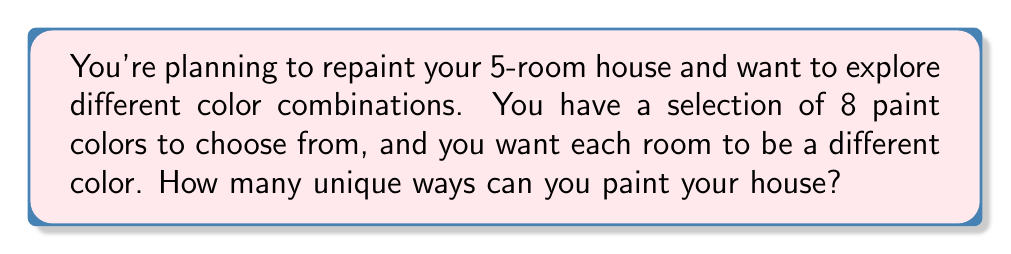Can you solve this math problem? To solve this problem, we need to use the concept of permutations from discrete mathematics. Here's a step-by-step explanation:

1. We have 5 rooms to paint, and each room must be a different color.
2. We have 8 colors to choose from.
3. This scenario is a permutation without repetition, as we're selecting colors without replacement (each color can only be used once).

The formula for permutations without repetition is:

$$P(n,r) = \frac{n!}{(n-r)!}$$

Where:
$n$ = total number of items to choose from (in this case, 8 colors)
$r$ = number of items being chosen (in this case, 5 rooms)

Let's plug in our values:

$$P(8,5) = \frac{8!}{(8-5)!} = \frac{8!}{3!}$$

Now, let's calculate:

$$\frac{8!}{3!} = \frac{8 \times 7 \times 6 \times 5 \times 4 \times 3!}{3!}$$

The $3!$ cancels out in the numerator and denominator:

$$= 8 \times 7 \times 6 \times 5 \times 4 = 6720$$

Therefore, there are 6720 unique ways to paint your 5-room house using 8 different colors.
Answer: 6720 unique color combinations 